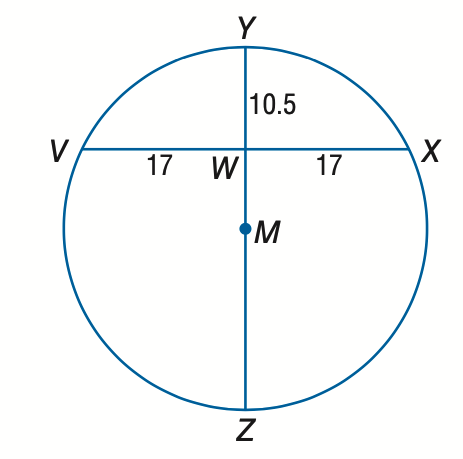Question: Find the diameter of circle M.
Choices:
A. 10.5
B. 27.5
C. 38.0
D. 42.5
Answer with the letter. Answer: C 